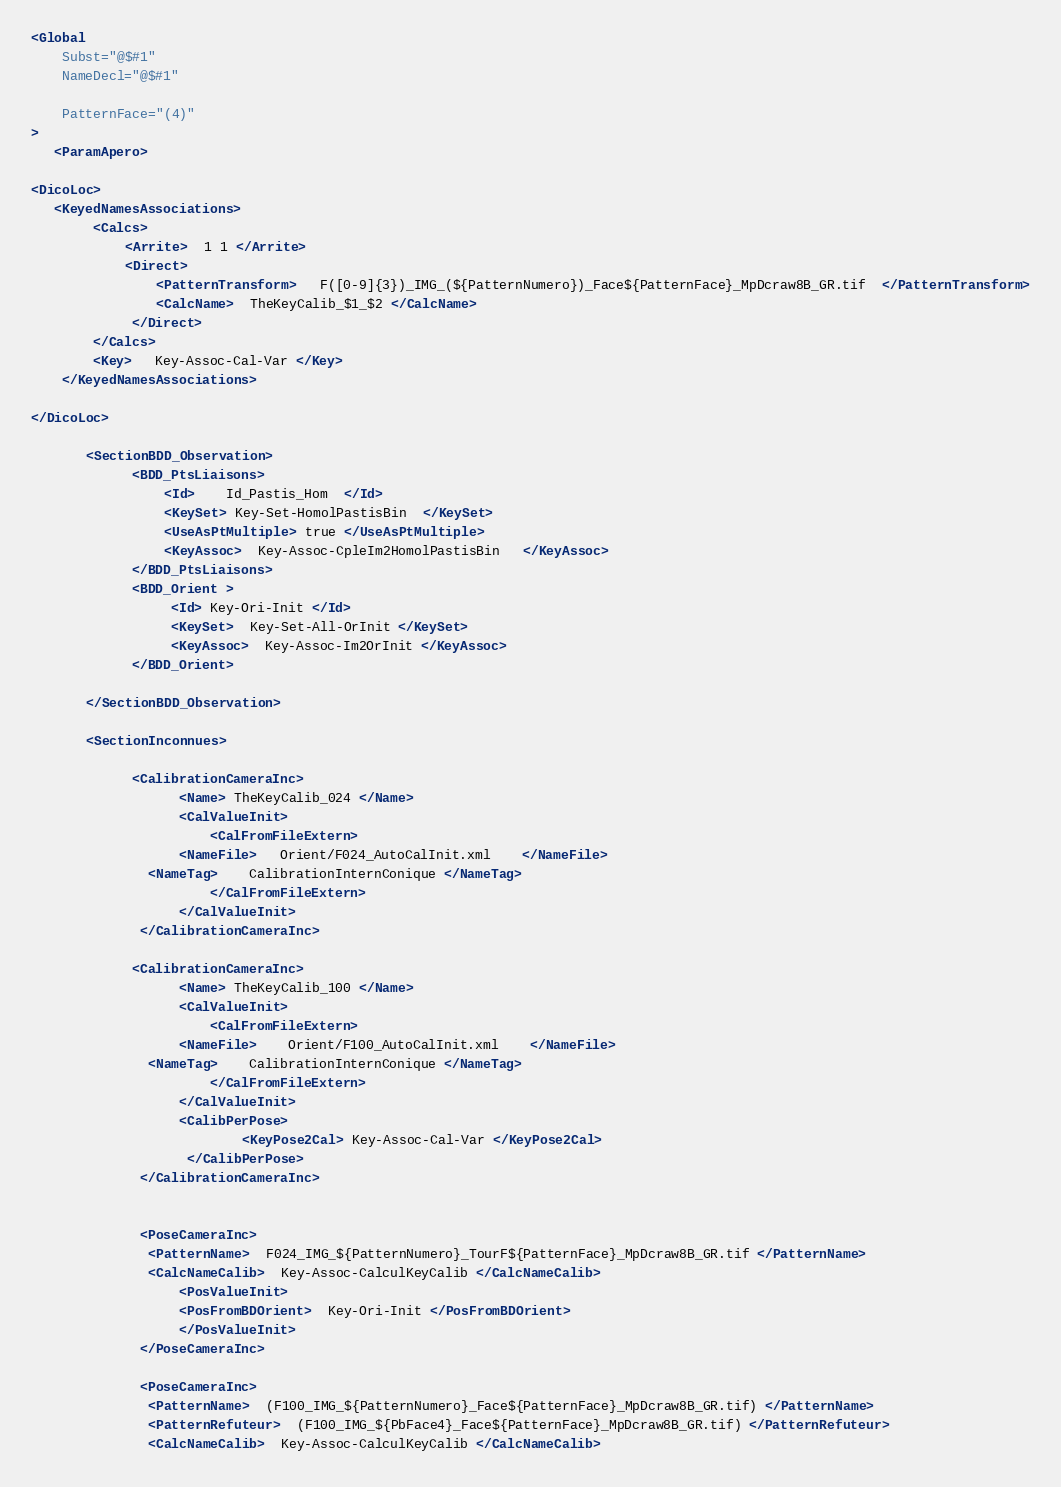<code> <loc_0><loc_0><loc_500><loc_500><_XML_><Global
    Subst="@$#1"
    NameDecl="@$#1"

    PatternFace="(4)"
>
   <ParamApero>

<DicoLoc>
   <KeyedNamesAssociations>
        <Calcs>
            <Arrite>  1 1 </Arrite>
            <Direct>
                <PatternTransform>   F([0-9]{3})_IMG_(${PatternNumero})_Face${PatternFace}_MpDcraw8B_GR.tif  </PatternTransform>
                <CalcName>  TheKeyCalib_$1_$2 </CalcName>
             </Direct>
        </Calcs>
        <Key>   Key-Assoc-Cal-Var </Key>
    </KeyedNamesAssociations>

</DicoLoc>

       <SectionBDD_Observation>
             <BDD_PtsLiaisons>
                 <Id>    Id_Pastis_Hom  </Id>
                 <KeySet> Key-Set-HomolPastisBin  </KeySet>
                 <UseAsPtMultiple> true </UseAsPtMultiple>
                 <KeyAssoc>  Key-Assoc-CpleIm2HomolPastisBin   </KeyAssoc>
             </BDD_PtsLiaisons>
             <BDD_Orient >
                  <Id> Key-Ori-Init </Id>
                  <KeySet>  Key-Set-All-OrInit </KeySet>
                  <KeyAssoc>  Key-Assoc-Im2OrInit </KeyAssoc>
             </BDD_Orient>

       </SectionBDD_Observation>

       <SectionInconnues>

             <CalibrationCameraInc>
                   <Name> TheKeyCalib_024 </Name>
                   <CalValueInit>
                       <CalFromFileExtern>
		           <NameFile>   Orient/F024_AutoCalInit.xml    </NameFile>
			   <NameTag>    CalibrationInternConique </NameTag>
                       </CalFromFileExtern>
                   </CalValueInit>
              </CalibrationCameraInc>

             <CalibrationCameraInc>
                   <Name> TheKeyCalib_100 </Name>
                   <CalValueInit>
                       <CalFromFileExtern>
		           <NameFile>    Orient/F100_AutoCalInit.xml    </NameFile>
			   <NameTag>    CalibrationInternConique </NameTag>
                       </CalFromFileExtern>
                   </CalValueInit>
                   <CalibPerPose>
                           <KeyPose2Cal> Key-Assoc-Cal-Var </KeyPose2Cal>
                    </CalibPerPose>
              </CalibrationCameraInc>


              <PoseCameraInc>
	           <PatternName>  F024_IMG_${PatternNumero}_TourF${PatternFace}_MpDcraw8B_GR.tif </PatternName>
	           <CalcNameCalib>  Key-Assoc-CalculKeyCalib </CalcNameCalib>
                   <PosValueInit>
	               <PosFromBDOrient>  Key-Ori-Init </PosFromBDOrient>
                   </PosValueInit>
              </PoseCameraInc>

              <PoseCameraInc>
	           <PatternName>  (F100_IMG_${PatternNumero}_Face${PatternFace}_MpDcraw8B_GR.tif) </PatternName>
	           <PatternRefuteur>  (F100_IMG_${PbFace4}_Face${PatternFace}_MpDcraw8B_GR.tif) </PatternRefuteur>
	           <CalcNameCalib>  Key-Assoc-CalculKeyCalib </CalcNameCalib></code> 